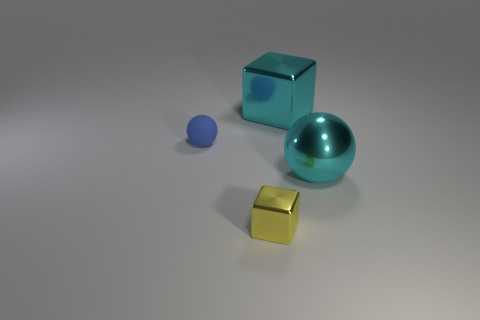Subtract 1 cubes. How many cubes are left? 1 Add 1 small rubber things. How many small rubber things exist? 2 Add 2 cubes. How many objects exist? 6 Subtract 0 gray spheres. How many objects are left? 4 Subtract all gray balls. Subtract all gray cubes. How many balls are left? 2 Subtract all cyan cubes. How many blue balls are left? 1 Subtract all big blue cylinders. Subtract all tiny blue rubber spheres. How many objects are left? 3 Add 2 yellow things. How many yellow things are left? 3 